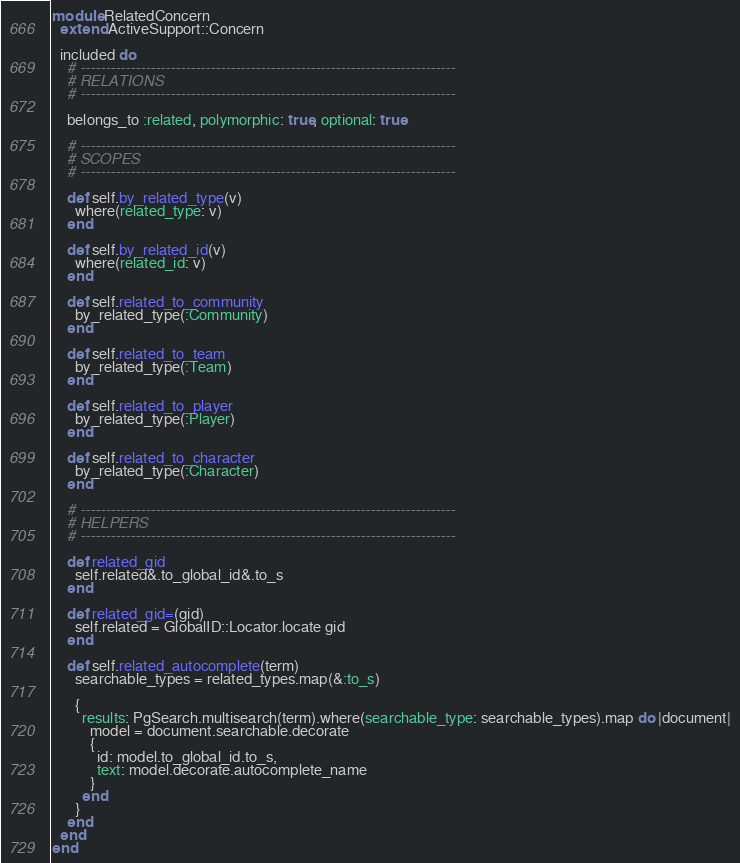<code> <loc_0><loc_0><loc_500><loc_500><_Ruby_>module RelatedConcern
  extend ActiveSupport::Concern

  included do
    # ---------------------------------------------------------------------------
    # RELATIONS
    # ---------------------------------------------------------------------------

    belongs_to :related, polymorphic: true, optional: true

    # ---------------------------------------------------------------------------
    # SCOPES
    # ---------------------------------------------------------------------------

    def self.by_related_type(v)
      where(related_type: v)
    end

    def self.by_related_id(v)
      where(related_id: v)
    end

    def self.related_to_community
      by_related_type(:Community)
    end

    def self.related_to_team
      by_related_type(:Team)
    end

    def self.related_to_player
      by_related_type(:Player)
    end

    def self.related_to_character
      by_related_type(:Character)
    end

    # ---------------------------------------------------------------------------
    # HELPERS
    # ---------------------------------------------------------------------------

    def related_gid
      self.related&.to_global_id&.to_s
    end

    def related_gid=(gid)
      self.related = GlobalID::Locator.locate gid
    end

    def self.related_autocomplete(term)
      searchable_types = related_types.map(&:to_s)

      {
        results: PgSearch.multisearch(term).where(searchable_type: searchable_types).map do |document|
          model = document.searchable.decorate
          {
            id: model.to_global_id.to_s,
            text: model.decorate.autocomplete_name
          }
        end
      }
    end
  end
end
</code> 